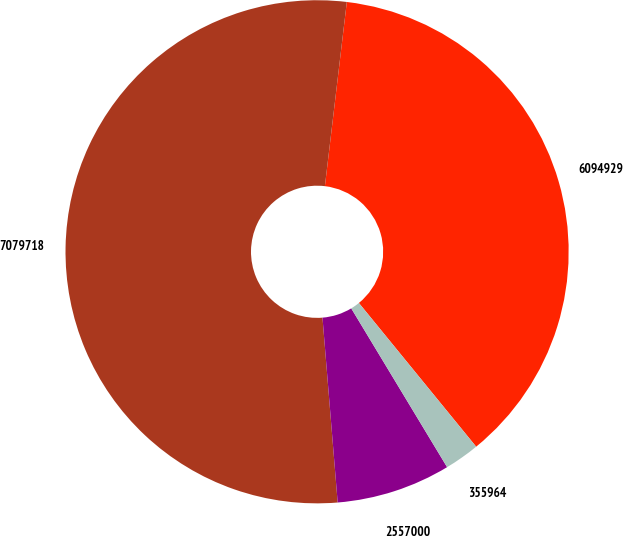Convert chart to OTSL. <chart><loc_0><loc_0><loc_500><loc_500><pie_chart><fcel>6094929<fcel>7079718<fcel>2557000<fcel>355964<nl><fcel>37.22%<fcel>53.19%<fcel>7.34%<fcel>2.25%<nl></chart> 